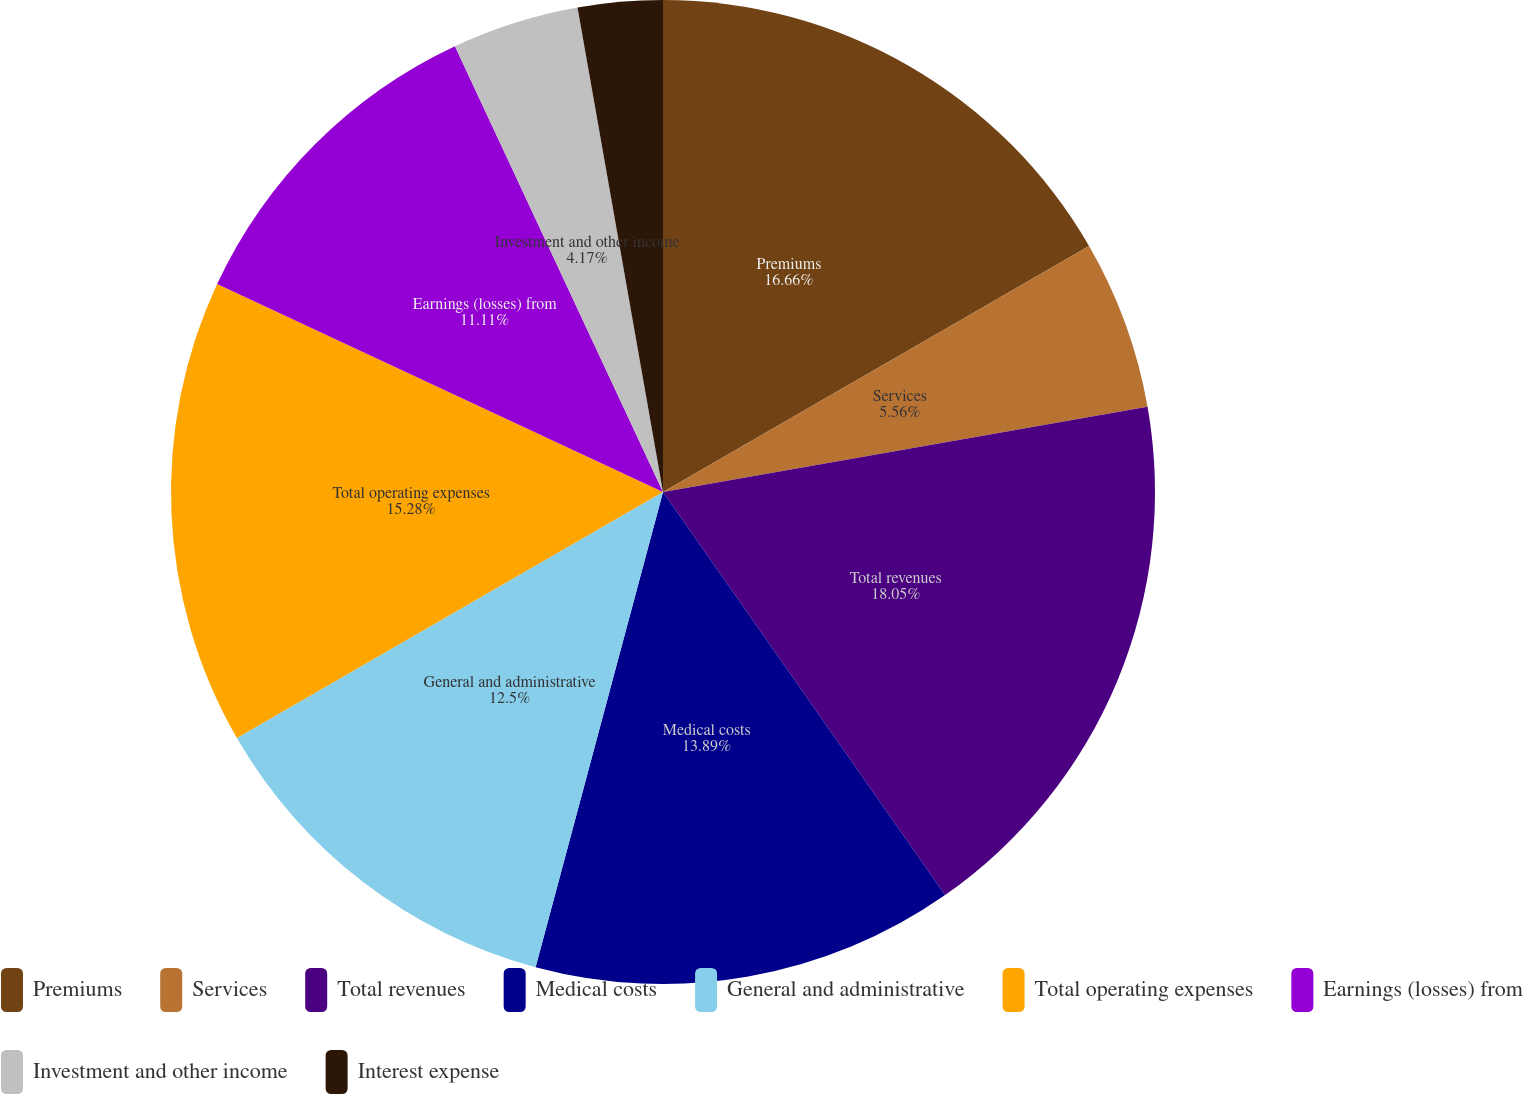Convert chart to OTSL. <chart><loc_0><loc_0><loc_500><loc_500><pie_chart><fcel>Premiums<fcel>Services<fcel>Total revenues<fcel>Medical costs<fcel>General and administrative<fcel>Total operating expenses<fcel>Earnings (losses) from<fcel>Investment and other income<fcel>Interest expense<nl><fcel>16.67%<fcel>5.56%<fcel>18.06%<fcel>13.89%<fcel>12.5%<fcel>15.28%<fcel>11.11%<fcel>4.17%<fcel>2.78%<nl></chart> 